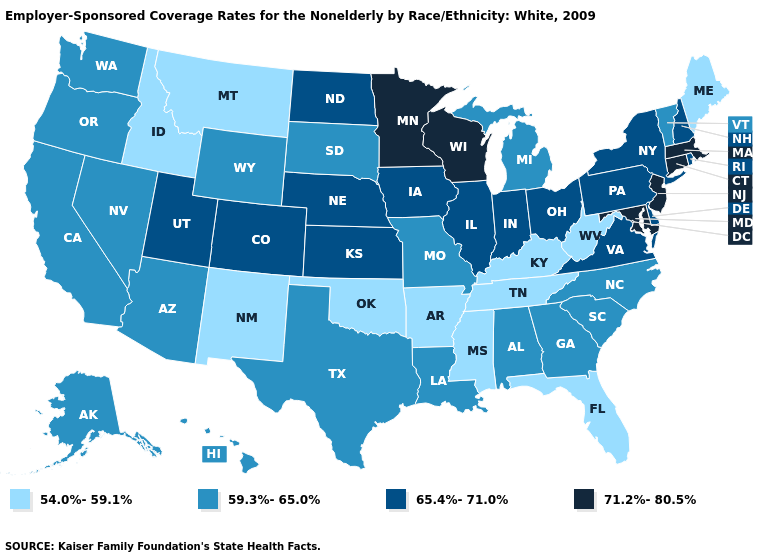Name the states that have a value in the range 71.2%-80.5%?
Short answer required. Connecticut, Maryland, Massachusetts, Minnesota, New Jersey, Wisconsin. What is the value of Florida?
Be succinct. 54.0%-59.1%. Which states have the lowest value in the USA?
Give a very brief answer. Arkansas, Florida, Idaho, Kentucky, Maine, Mississippi, Montana, New Mexico, Oklahoma, Tennessee, West Virginia. Is the legend a continuous bar?
Give a very brief answer. No. Does Iowa have a higher value than Connecticut?
Concise answer only. No. Which states have the lowest value in the USA?
Short answer required. Arkansas, Florida, Idaho, Kentucky, Maine, Mississippi, Montana, New Mexico, Oklahoma, Tennessee, West Virginia. How many symbols are there in the legend?
Concise answer only. 4. Which states have the lowest value in the South?
Be succinct. Arkansas, Florida, Kentucky, Mississippi, Oklahoma, Tennessee, West Virginia. Does Illinois have the same value as Utah?
Concise answer only. Yes. What is the lowest value in states that border Louisiana?
Write a very short answer. 54.0%-59.1%. Name the states that have a value in the range 59.3%-65.0%?
Give a very brief answer. Alabama, Alaska, Arizona, California, Georgia, Hawaii, Louisiana, Michigan, Missouri, Nevada, North Carolina, Oregon, South Carolina, South Dakota, Texas, Vermont, Washington, Wyoming. Does Idaho have the same value as Florida?
Give a very brief answer. Yes. What is the lowest value in states that border Nevada?
Quick response, please. 54.0%-59.1%. What is the value of Minnesota?
Give a very brief answer. 71.2%-80.5%. What is the value of New Hampshire?
Write a very short answer. 65.4%-71.0%. 